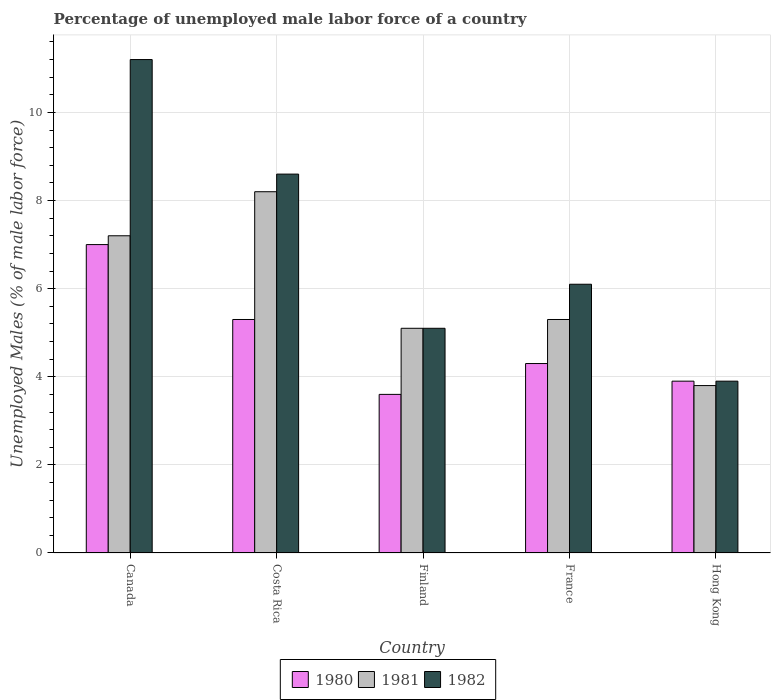Are the number of bars per tick equal to the number of legend labels?
Offer a terse response. Yes. Are the number of bars on each tick of the X-axis equal?
Your response must be concise. Yes. How many bars are there on the 4th tick from the left?
Provide a short and direct response. 3. How many bars are there on the 1st tick from the right?
Offer a very short reply. 3. What is the label of the 2nd group of bars from the left?
Provide a succinct answer. Costa Rica. In how many cases, is the number of bars for a given country not equal to the number of legend labels?
Ensure brevity in your answer.  0. What is the percentage of unemployed male labor force in 1982 in Hong Kong?
Offer a very short reply. 3.9. Across all countries, what is the minimum percentage of unemployed male labor force in 1980?
Offer a terse response. 3.6. In which country was the percentage of unemployed male labor force in 1981 minimum?
Offer a very short reply. Hong Kong. What is the total percentage of unemployed male labor force in 1982 in the graph?
Ensure brevity in your answer.  34.9. What is the difference between the percentage of unemployed male labor force in 1980 in Canada and that in France?
Keep it short and to the point. 2.7. What is the difference between the percentage of unemployed male labor force in 1980 in Canada and the percentage of unemployed male labor force in 1982 in Costa Rica?
Your response must be concise. -1.6. What is the average percentage of unemployed male labor force in 1981 per country?
Keep it short and to the point. 5.92. What is the difference between the percentage of unemployed male labor force of/in 1982 and percentage of unemployed male labor force of/in 1981 in France?
Your answer should be compact. 0.8. What is the ratio of the percentage of unemployed male labor force in 1980 in France to that in Hong Kong?
Your answer should be compact. 1.1. What is the difference between the highest and the second highest percentage of unemployed male labor force in 1980?
Your answer should be compact. -1. What is the difference between the highest and the lowest percentage of unemployed male labor force in 1981?
Make the answer very short. 4.4. What does the 2nd bar from the left in Canada represents?
Your answer should be compact. 1981. Is it the case that in every country, the sum of the percentage of unemployed male labor force in 1980 and percentage of unemployed male labor force in 1982 is greater than the percentage of unemployed male labor force in 1981?
Ensure brevity in your answer.  Yes. How many bars are there?
Ensure brevity in your answer.  15. Are all the bars in the graph horizontal?
Keep it short and to the point. No. How many countries are there in the graph?
Provide a short and direct response. 5. Does the graph contain any zero values?
Offer a terse response. No. Does the graph contain grids?
Ensure brevity in your answer.  Yes. How many legend labels are there?
Your response must be concise. 3. What is the title of the graph?
Your answer should be very brief. Percentage of unemployed male labor force of a country. What is the label or title of the Y-axis?
Your response must be concise. Unemployed Males (% of male labor force). What is the Unemployed Males (% of male labor force) in 1981 in Canada?
Your answer should be compact. 7.2. What is the Unemployed Males (% of male labor force) in 1982 in Canada?
Make the answer very short. 11.2. What is the Unemployed Males (% of male labor force) of 1980 in Costa Rica?
Give a very brief answer. 5.3. What is the Unemployed Males (% of male labor force) of 1981 in Costa Rica?
Offer a very short reply. 8.2. What is the Unemployed Males (% of male labor force) of 1982 in Costa Rica?
Your response must be concise. 8.6. What is the Unemployed Males (% of male labor force) of 1980 in Finland?
Ensure brevity in your answer.  3.6. What is the Unemployed Males (% of male labor force) in 1981 in Finland?
Ensure brevity in your answer.  5.1. What is the Unemployed Males (% of male labor force) of 1982 in Finland?
Give a very brief answer. 5.1. What is the Unemployed Males (% of male labor force) in 1980 in France?
Provide a short and direct response. 4.3. What is the Unemployed Males (% of male labor force) of 1981 in France?
Your answer should be compact. 5.3. What is the Unemployed Males (% of male labor force) of 1982 in France?
Ensure brevity in your answer.  6.1. What is the Unemployed Males (% of male labor force) in 1980 in Hong Kong?
Ensure brevity in your answer.  3.9. What is the Unemployed Males (% of male labor force) in 1981 in Hong Kong?
Your response must be concise. 3.8. What is the Unemployed Males (% of male labor force) in 1982 in Hong Kong?
Offer a terse response. 3.9. Across all countries, what is the maximum Unemployed Males (% of male labor force) in 1980?
Your response must be concise. 7. Across all countries, what is the maximum Unemployed Males (% of male labor force) of 1981?
Your answer should be compact. 8.2. Across all countries, what is the maximum Unemployed Males (% of male labor force) of 1982?
Ensure brevity in your answer.  11.2. Across all countries, what is the minimum Unemployed Males (% of male labor force) in 1980?
Your answer should be very brief. 3.6. Across all countries, what is the minimum Unemployed Males (% of male labor force) of 1981?
Offer a very short reply. 3.8. Across all countries, what is the minimum Unemployed Males (% of male labor force) of 1982?
Provide a succinct answer. 3.9. What is the total Unemployed Males (% of male labor force) of 1980 in the graph?
Your response must be concise. 24.1. What is the total Unemployed Males (% of male labor force) of 1981 in the graph?
Offer a terse response. 29.6. What is the total Unemployed Males (% of male labor force) of 1982 in the graph?
Your response must be concise. 34.9. What is the difference between the Unemployed Males (% of male labor force) of 1980 in Canada and that in Costa Rica?
Give a very brief answer. 1.7. What is the difference between the Unemployed Males (% of male labor force) in 1980 in Canada and that in Finland?
Your answer should be compact. 3.4. What is the difference between the Unemployed Males (% of male labor force) of 1982 in Canada and that in France?
Give a very brief answer. 5.1. What is the difference between the Unemployed Males (% of male labor force) in 1980 in Costa Rica and that in Finland?
Provide a short and direct response. 1.7. What is the difference between the Unemployed Males (% of male labor force) of 1980 in Costa Rica and that in France?
Your answer should be very brief. 1. What is the difference between the Unemployed Males (% of male labor force) in 1981 in Costa Rica and that in Hong Kong?
Offer a very short reply. 4.4. What is the difference between the Unemployed Males (% of male labor force) in 1982 in Costa Rica and that in Hong Kong?
Your answer should be compact. 4.7. What is the difference between the Unemployed Males (% of male labor force) of 1980 in Finland and that in France?
Your response must be concise. -0.7. What is the difference between the Unemployed Males (% of male labor force) of 1981 in Finland and that in France?
Your response must be concise. -0.2. What is the difference between the Unemployed Males (% of male labor force) of 1980 in Finland and that in Hong Kong?
Ensure brevity in your answer.  -0.3. What is the difference between the Unemployed Males (% of male labor force) in 1981 in Finland and that in Hong Kong?
Offer a terse response. 1.3. What is the difference between the Unemployed Males (% of male labor force) in 1982 in France and that in Hong Kong?
Give a very brief answer. 2.2. What is the difference between the Unemployed Males (% of male labor force) in 1980 in Canada and the Unemployed Males (% of male labor force) in 1982 in Finland?
Your response must be concise. 1.9. What is the difference between the Unemployed Males (% of male labor force) of 1981 in Canada and the Unemployed Males (% of male labor force) of 1982 in Finland?
Make the answer very short. 2.1. What is the difference between the Unemployed Males (% of male labor force) of 1980 in Canada and the Unemployed Males (% of male labor force) of 1981 in France?
Provide a short and direct response. 1.7. What is the difference between the Unemployed Males (% of male labor force) of 1980 in Canada and the Unemployed Males (% of male labor force) of 1982 in France?
Provide a succinct answer. 0.9. What is the difference between the Unemployed Males (% of male labor force) of 1981 in Canada and the Unemployed Males (% of male labor force) of 1982 in France?
Your answer should be compact. 1.1. What is the difference between the Unemployed Males (% of male labor force) in 1980 in Canada and the Unemployed Males (% of male labor force) in 1981 in Hong Kong?
Ensure brevity in your answer.  3.2. What is the difference between the Unemployed Males (% of male labor force) in 1980 in Canada and the Unemployed Males (% of male labor force) in 1982 in Hong Kong?
Your answer should be compact. 3.1. What is the difference between the Unemployed Males (% of male labor force) of 1981 in Canada and the Unemployed Males (% of male labor force) of 1982 in Hong Kong?
Offer a terse response. 3.3. What is the difference between the Unemployed Males (% of male labor force) of 1980 in Costa Rica and the Unemployed Males (% of male labor force) of 1981 in Finland?
Provide a succinct answer. 0.2. What is the difference between the Unemployed Males (% of male labor force) of 1980 in Costa Rica and the Unemployed Males (% of male labor force) of 1982 in Finland?
Provide a short and direct response. 0.2. What is the difference between the Unemployed Males (% of male labor force) in 1980 in Costa Rica and the Unemployed Males (% of male labor force) in 1982 in France?
Your answer should be very brief. -0.8. What is the difference between the Unemployed Males (% of male labor force) in 1980 in Costa Rica and the Unemployed Males (% of male labor force) in 1981 in Hong Kong?
Make the answer very short. 1.5. What is the difference between the Unemployed Males (% of male labor force) in 1980 in Finland and the Unemployed Males (% of male labor force) in 1982 in France?
Provide a short and direct response. -2.5. What is the difference between the Unemployed Males (% of male labor force) of 1981 in Finland and the Unemployed Males (% of male labor force) of 1982 in France?
Offer a very short reply. -1. What is the difference between the Unemployed Males (% of male labor force) of 1980 in Finland and the Unemployed Males (% of male labor force) of 1981 in Hong Kong?
Give a very brief answer. -0.2. What is the difference between the Unemployed Males (% of male labor force) of 1980 in Finland and the Unemployed Males (% of male labor force) of 1982 in Hong Kong?
Offer a very short reply. -0.3. What is the difference between the Unemployed Males (% of male labor force) of 1980 in France and the Unemployed Males (% of male labor force) of 1982 in Hong Kong?
Offer a very short reply. 0.4. What is the difference between the Unemployed Males (% of male labor force) in 1981 in France and the Unemployed Males (% of male labor force) in 1982 in Hong Kong?
Provide a succinct answer. 1.4. What is the average Unemployed Males (% of male labor force) of 1980 per country?
Your answer should be very brief. 4.82. What is the average Unemployed Males (% of male labor force) in 1981 per country?
Offer a very short reply. 5.92. What is the average Unemployed Males (% of male labor force) in 1982 per country?
Provide a succinct answer. 6.98. What is the difference between the Unemployed Males (% of male labor force) in 1980 and Unemployed Males (% of male labor force) in 1981 in Canada?
Provide a short and direct response. -0.2. What is the difference between the Unemployed Males (% of male labor force) of 1981 and Unemployed Males (% of male labor force) of 1982 in Costa Rica?
Your answer should be very brief. -0.4. What is the difference between the Unemployed Males (% of male labor force) in 1980 and Unemployed Males (% of male labor force) in 1981 in Hong Kong?
Provide a succinct answer. 0.1. What is the difference between the Unemployed Males (% of male labor force) of 1980 and Unemployed Males (% of male labor force) of 1982 in Hong Kong?
Your answer should be very brief. 0. What is the difference between the Unemployed Males (% of male labor force) in 1981 and Unemployed Males (% of male labor force) in 1982 in Hong Kong?
Your answer should be very brief. -0.1. What is the ratio of the Unemployed Males (% of male labor force) of 1980 in Canada to that in Costa Rica?
Your answer should be compact. 1.32. What is the ratio of the Unemployed Males (% of male labor force) in 1981 in Canada to that in Costa Rica?
Your answer should be very brief. 0.88. What is the ratio of the Unemployed Males (% of male labor force) in 1982 in Canada to that in Costa Rica?
Give a very brief answer. 1.3. What is the ratio of the Unemployed Males (% of male labor force) of 1980 in Canada to that in Finland?
Provide a succinct answer. 1.94. What is the ratio of the Unemployed Males (% of male labor force) of 1981 in Canada to that in Finland?
Give a very brief answer. 1.41. What is the ratio of the Unemployed Males (% of male labor force) in 1982 in Canada to that in Finland?
Keep it short and to the point. 2.2. What is the ratio of the Unemployed Males (% of male labor force) of 1980 in Canada to that in France?
Your answer should be very brief. 1.63. What is the ratio of the Unemployed Males (% of male labor force) in 1981 in Canada to that in France?
Offer a terse response. 1.36. What is the ratio of the Unemployed Males (% of male labor force) in 1982 in Canada to that in France?
Offer a terse response. 1.84. What is the ratio of the Unemployed Males (% of male labor force) in 1980 in Canada to that in Hong Kong?
Your answer should be compact. 1.79. What is the ratio of the Unemployed Males (% of male labor force) of 1981 in Canada to that in Hong Kong?
Provide a succinct answer. 1.89. What is the ratio of the Unemployed Males (% of male labor force) of 1982 in Canada to that in Hong Kong?
Your answer should be compact. 2.87. What is the ratio of the Unemployed Males (% of male labor force) of 1980 in Costa Rica to that in Finland?
Make the answer very short. 1.47. What is the ratio of the Unemployed Males (% of male labor force) in 1981 in Costa Rica to that in Finland?
Keep it short and to the point. 1.61. What is the ratio of the Unemployed Males (% of male labor force) of 1982 in Costa Rica to that in Finland?
Your answer should be very brief. 1.69. What is the ratio of the Unemployed Males (% of male labor force) of 1980 in Costa Rica to that in France?
Ensure brevity in your answer.  1.23. What is the ratio of the Unemployed Males (% of male labor force) of 1981 in Costa Rica to that in France?
Your response must be concise. 1.55. What is the ratio of the Unemployed Males (% of male labor force) in 1982 in Costa Rica to that in France?
Your response must be concise. 1.41. What is the ratio of the Unemployed Males (% of male labor force) in 1980 in Costa Rica to that in Hong Kong?
Your answer should be compact. 1.36. What is the ratio of the Unemployed Males (% of male labor force) in 1981 in Costa Rica to that in Hong Kong?
Make the answer very short. 2.16. What is the ratio of the Unemployed Males (% of male labor force) of 1982 in Costa Rica to that in Hong Kong?
Offer a very short reply. 2.21. What is the ratio of the Unemployed Males (% of male labor force) of 1980 in Finland to that in France?
Provide a succinct answer. 0.84. What is the ratio of the Unemployed Males (% of male labor force) in 1981 in Finland to that in France?
Your answer should be compact. 0.96. What is the ratio of the Unemployed Males (% of male labor force) of 1982 in Finland to that in France?
Keep it short and to the point. 0.84. What is the ratio of the Unemployed Males (% of male labor force) in 1981 in Finland to that in Hong Kong?
Your response must be concise. 1.34. What is the ratio of the Unemployed Males (% of male labor force) in 1982 in Finland to that in Hong Kong?
Your answer should be compact. 1.31. What is the ratio of the Unemployed Males (% of male labor force) in 1980 in France to that in Hong Kong?
Give a very brief answer. 1.1. What is the ratio of the Unemployed Males (% of male labor force) in 1981 in France to that in Hong Kong?
Provide a short and direct response. 1.39. What is the ratio of the Unemployed Males (% of male labor force) of 1982 in France to that in Hong Kong?
Ensure brevity in your answer.  1.56. What is the difference between the highest and the lowest Unemployed Males (% of male labor force) of 1982?
Your answer should be very brief. 7.3. 